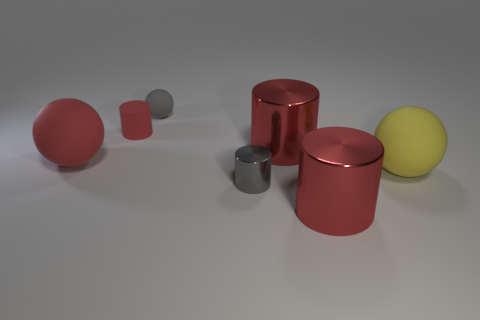Subtract all cyan blocks. How many red cylinders are left? 3 Add 1 large blue metal spheres. How many objects exist? 8 Subtract all cylinders. How many objects are left? 3 Add 4 gray matte objects. How many gray matte objects exist? 5 Subtract 0 cyan cylinders. How many objects are left? 7 Subtract all big rubber spheres. Subtract all small gray spheres. How many objects are left? 4 Add 3 matte cylinders. How many matte cylinders are left? 4 